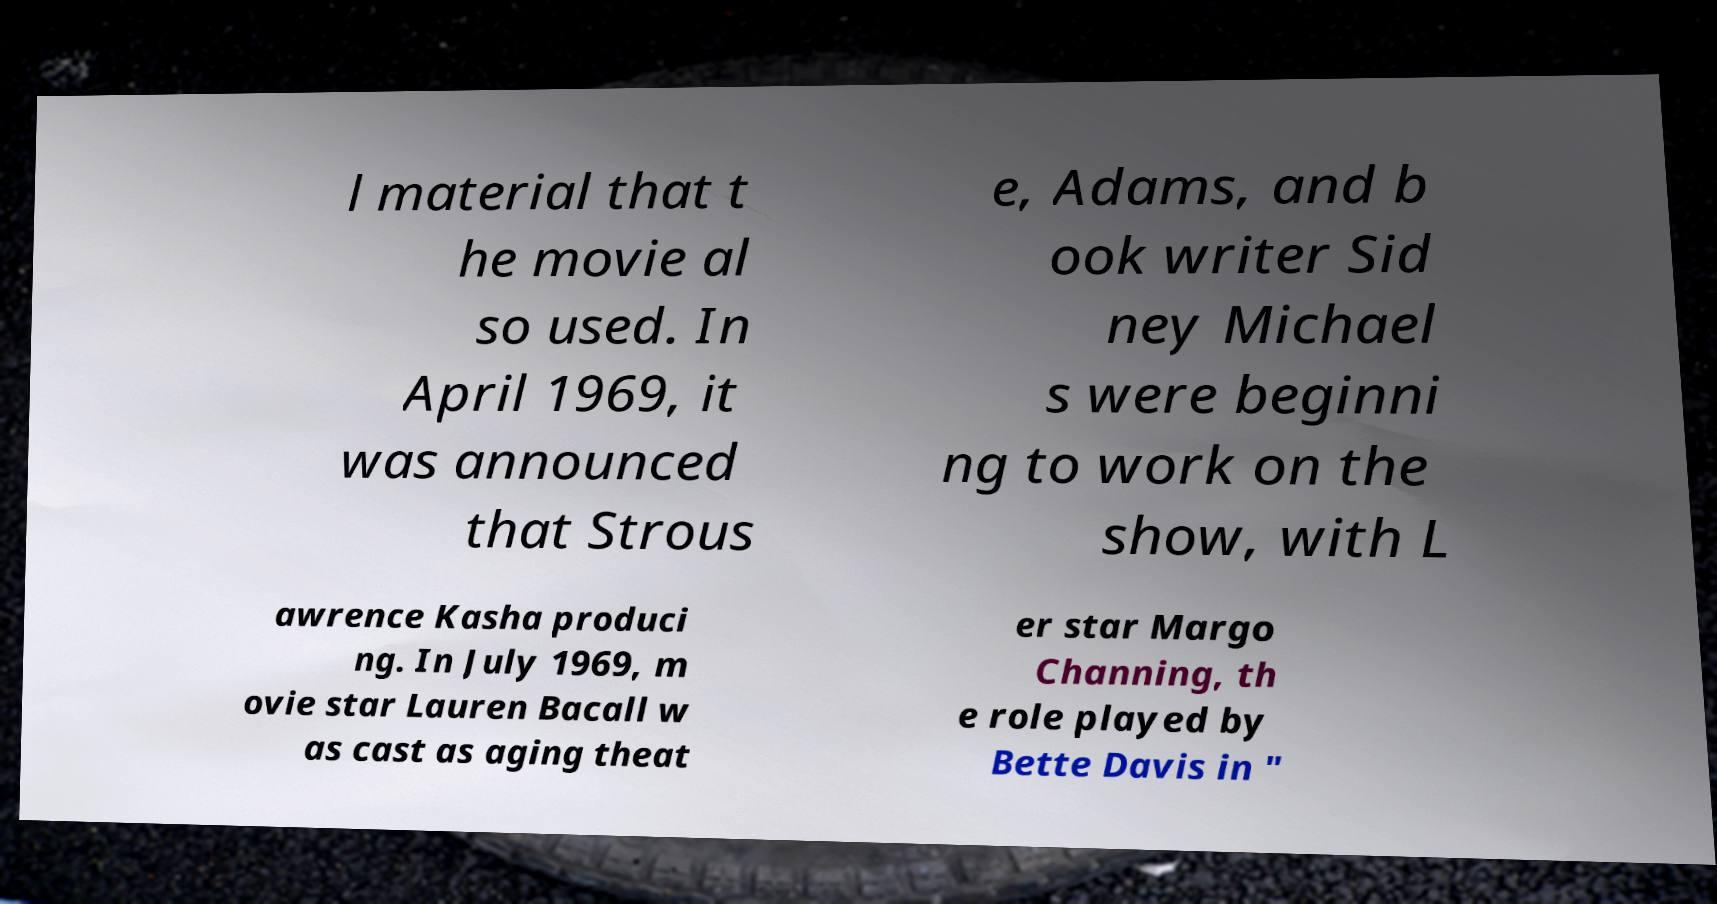What messages or text are displayed in this image? I need them in a readable, typed format. l material that t he movie al so used. In April 1969, it was announced that Strous e, Adams, and b ook writer Sid ney Michael s were beginni ng to work on the show, with L awrence Kasha produci ng. In July 1969, m ovie star Lauren Bacall w as cast as aging theat er star Margo Channing, th e role played by Bette Davis in " 